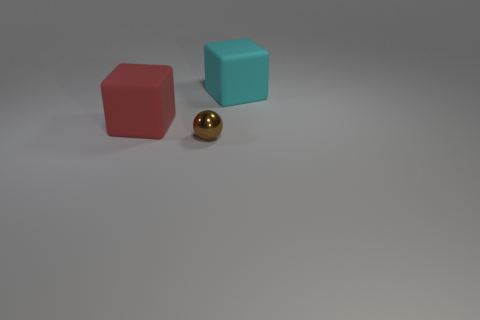Add 3 green things. How many objects exist? 6 Subtract all blocks. How many objects are left? 1 Subtract all blue cylinders. Subtract all big red matte blocks. How many objects are left? 2 Add 2 matte cubes. How many matte cubes are left? 4 Add 2 small balls. How many small balls exist? 3 Subtract 1 brown balls. How many objects are left? 2 